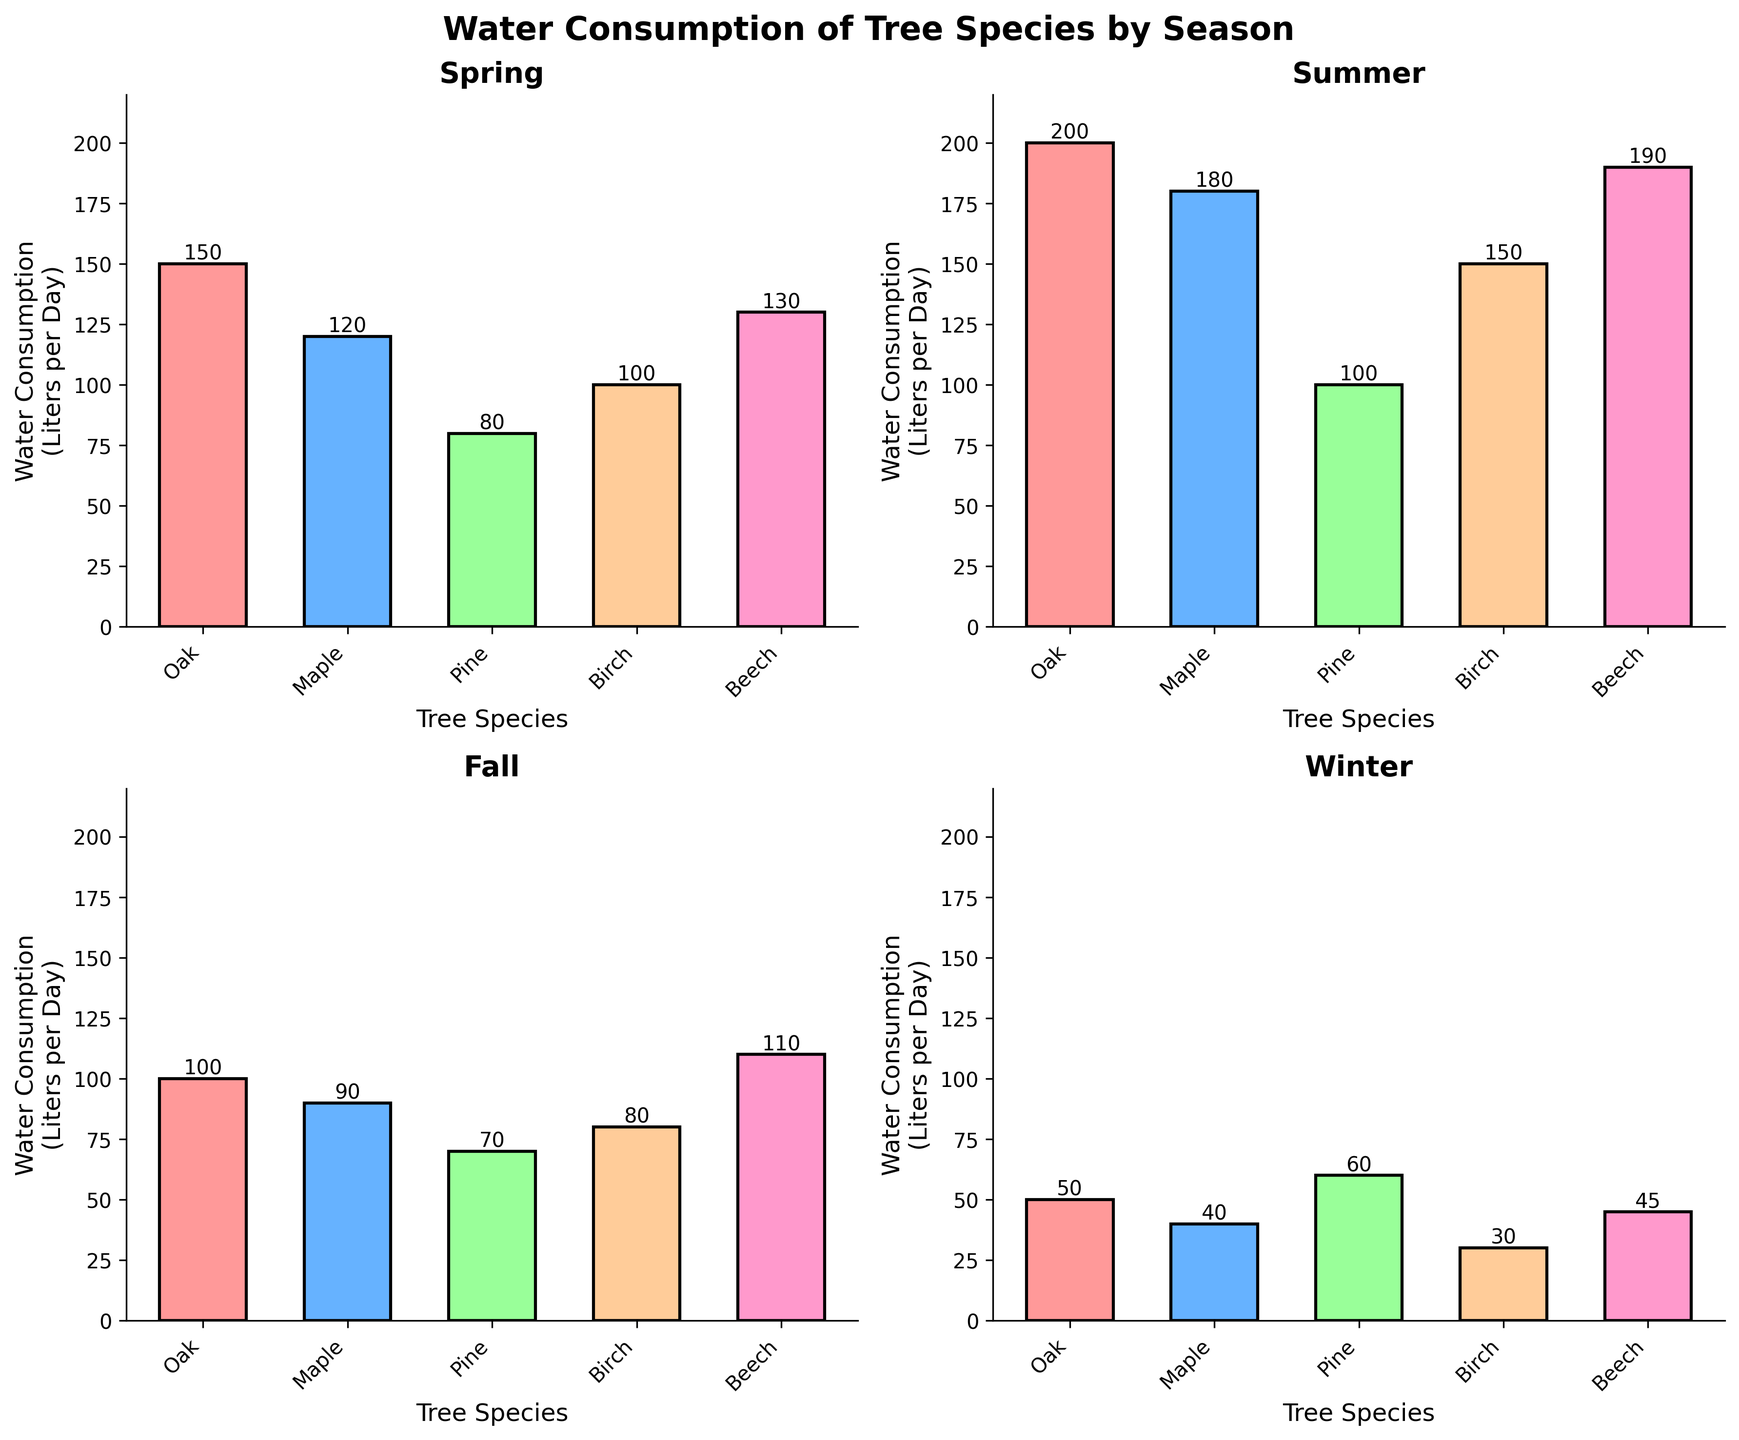Which tree species has the highest water consumption in the summer? Look at the subplot titled "Summer". Among the bars representing different tree species, the one with the maximum height corresponds to the tree species with the highest water consumption.
Answer: Oak Comparing spring and fall, which season has higher water consumption for the Birch species? First, locate the heights of the Birch species bars in both the "Spring" and "Fall" subplots. Then compare these heights to see which is taller.
Answer: Spring What is the average water consumption of the Pine species across all seasons? Sum the water consumption values for Pine in all four seasons (80 + 100 + 70 + 60). Then divide by the number of seasons (4). The calculation is (80 + 100 + 70 + 60) / 4 = 77.5.
Answer: 77.5 liters per day Which two tree species have the closest water consumption in the winter? Look at the heights of the bars in the "Winter" subplot. Compare each pair of heights to see which two are closest in magnitude.
Answer: Pine and Beech How much more water does the Beech species consume in the summer compared to the winter? Identify the heights of the Beech species bars in the "Summer" and "Winter" subplots. Calculate the difference: 190 - 45 = 145.
Answer: 145 liters per day Which season shows the greatest difference between the highest and lowest water consumption among tree species? For each subplot, find the heights of the highest and lowest bars and calculate their differences. Compare these differences across all subplots to see which is greatest.
Answer: Summer 